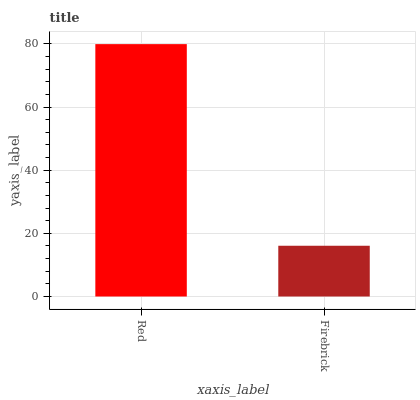Is Firebrick the maximum?
Answer yes or no. No. Is Red greater than Firebrick?
Answer yes or no. Yes. Is Firebrick less than Red?
Answer yes or no. Yes. Is Firebrick greater than Red?
Answer yes or no. No. Is Red less than Firebrick?
Answer yes or no. No. Is Red the high median?
Answer yes or no. Yes. Is Firebrick the low median?
Answer yes or no. Yes. Is Firebrick the high median?
Answer yes or no. No. Is Red the low median?
Answer yes or no. No. 